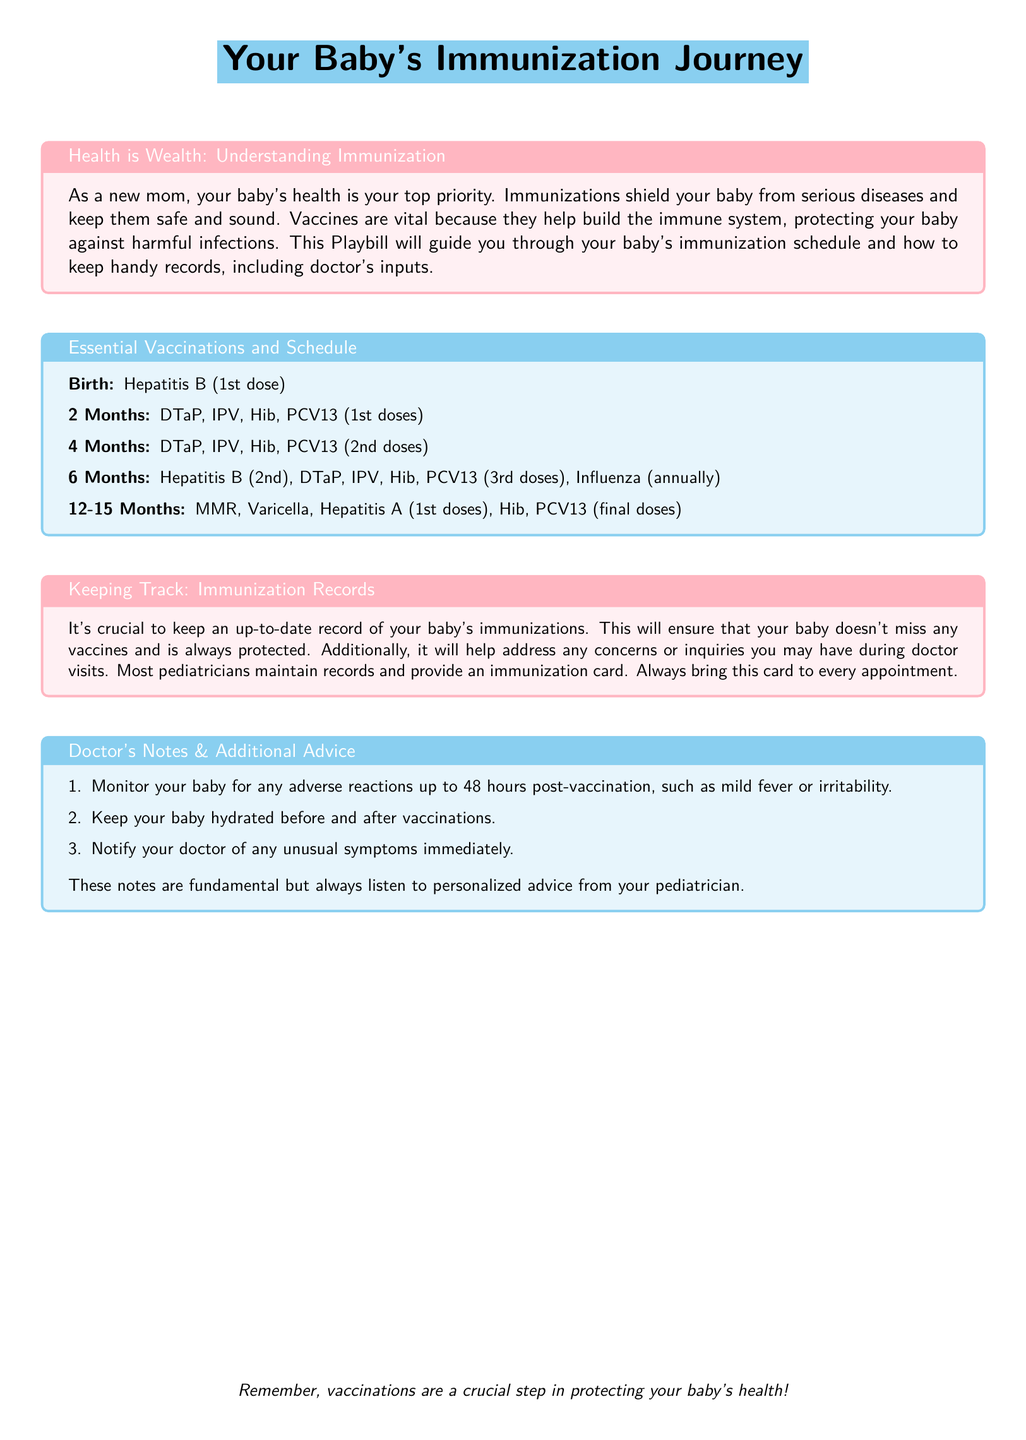What is the first vaccination given at birth? The first vaccination listed in the document for birth is Hepatitis B (1st dose).
Answer: Hepatitis B (1st dose) How many doses of DTaP are given by 12-15 months? The document mentions 1 dose at 2 months, 1 at 4 months, and 1 at 12-15 months, totaling 3 doses of DTaP.
Answer: 3 doses What is the vaccination given annually starting at 6 months? The document states that Influenza vaccinations are given annually starting at 6 months.
Answer: Influenza What should you do if unusual symptoms occur after vaccination? The document advises notifying your doctor of any unusual symptoms immediately after vaccination.
Answer: Notify your doctor What color is the background of the title section? The section's background color is described as baby blue in the document.
Answer: baby blue What are the ages for administering the MMR vaccine according to the schedule? The document specifies that the MMR vaccine is administered between 12-15 months.
Answer: 12-15 months How many doses of Hepatitis B are noted in the schedule? The schedule indicates that there are 2 doses of Hepatitis B listed in the immunization schedule.
Answer: 2 doses Which section emphasizes the importance of keeping records? The section titled "Keeping Track: Immunization Records" emphasizes the importance of maintaining up-to-date records.
Answer: Keeping Track: Immunization Records What is one adverse reaction to monitor post-vaccination? The document suggests monitoring for a mild fever as one possible adverse reaction up to 48 hours after vaccination.
Answer: mild fever 